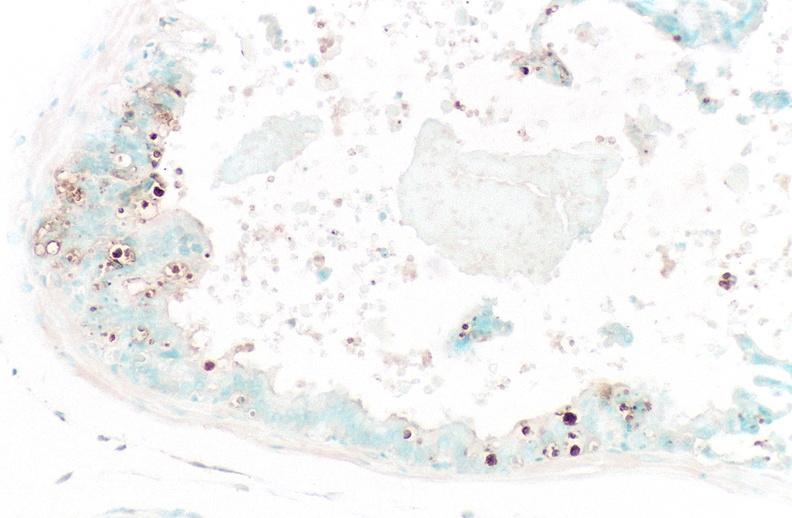what does this image show?
Answer the question using a single word or phrase. Prostate 